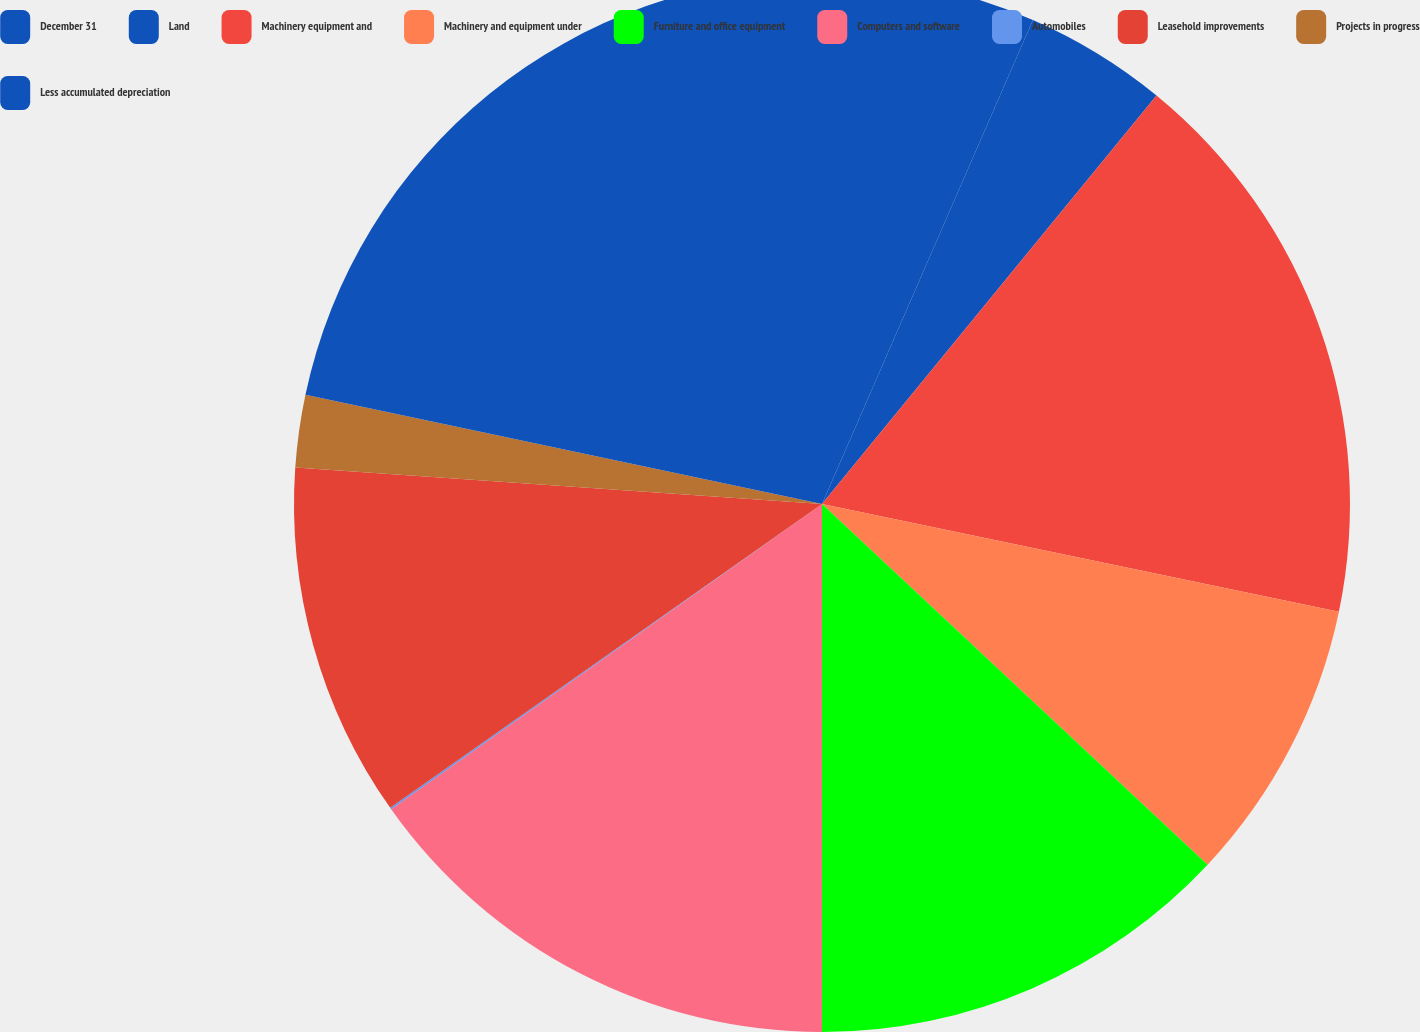Convert chart. <chart><loc_0><loc_0><loc_500><loc_500><pie_chart><fcel>December 31<fcel>Land<fcel>Machinery equipment and<fcel>Machinery and equipment under<fcel>Furniture and office equipment<fcel>Computers and software<fcel>Automobiles<fcel>Leasehold improvements<fcel>Projects in progress<fcel>Less accumulated depreciation<nl><fcel>6.54%<fcel>4.38%<fcel>17.35%<fcel>8.7%<fcel>13.03%<fcel>15.19%<fcel>0.05%<fcel>10.86%<fcel>2.22%<fcel>21.68%<nl></chart> 